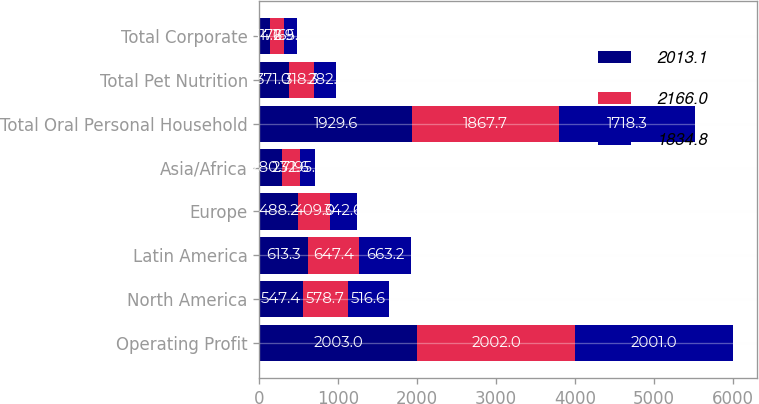<chart> <loc_0><loc_0><loc_500><loc_500><stacked_bar_chart><ecel><fcel>Operating Profit<fcel>North America<fcel>Latin America<fcel>Europe<fcel>Asia/Africa<fcel>Total Oral Personal Household<fcel>Total Pet Nutrition<fcel>Total Corporate<nl><fcel>2013.1<fcel>2003<fcel>547.4<fcel>613.3<fcel>488.2<fcel>280.7<fcel>1929.6<fcel>371<fcel>134.6<nl><fcel>2166<fcel>2002<fcel>578.7<fcel>647.4<fcel>409<fcel>232.6<fcel>1867.7<fcel>318.3<fcel>172.9<nl><fcel>1834.8<fcel>2001<fcel>516.6<fcel>663.2<fcel>342.6<fcel>195.9<fcel>1718.3<fcel>282.1<fcel>165.6<nl></chart> 